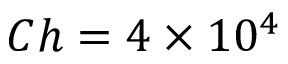<formula> <loc_0><loc_0><loc_500><loc_500>C h = 4 \times 1 0 ^ { 4 }</formula> 